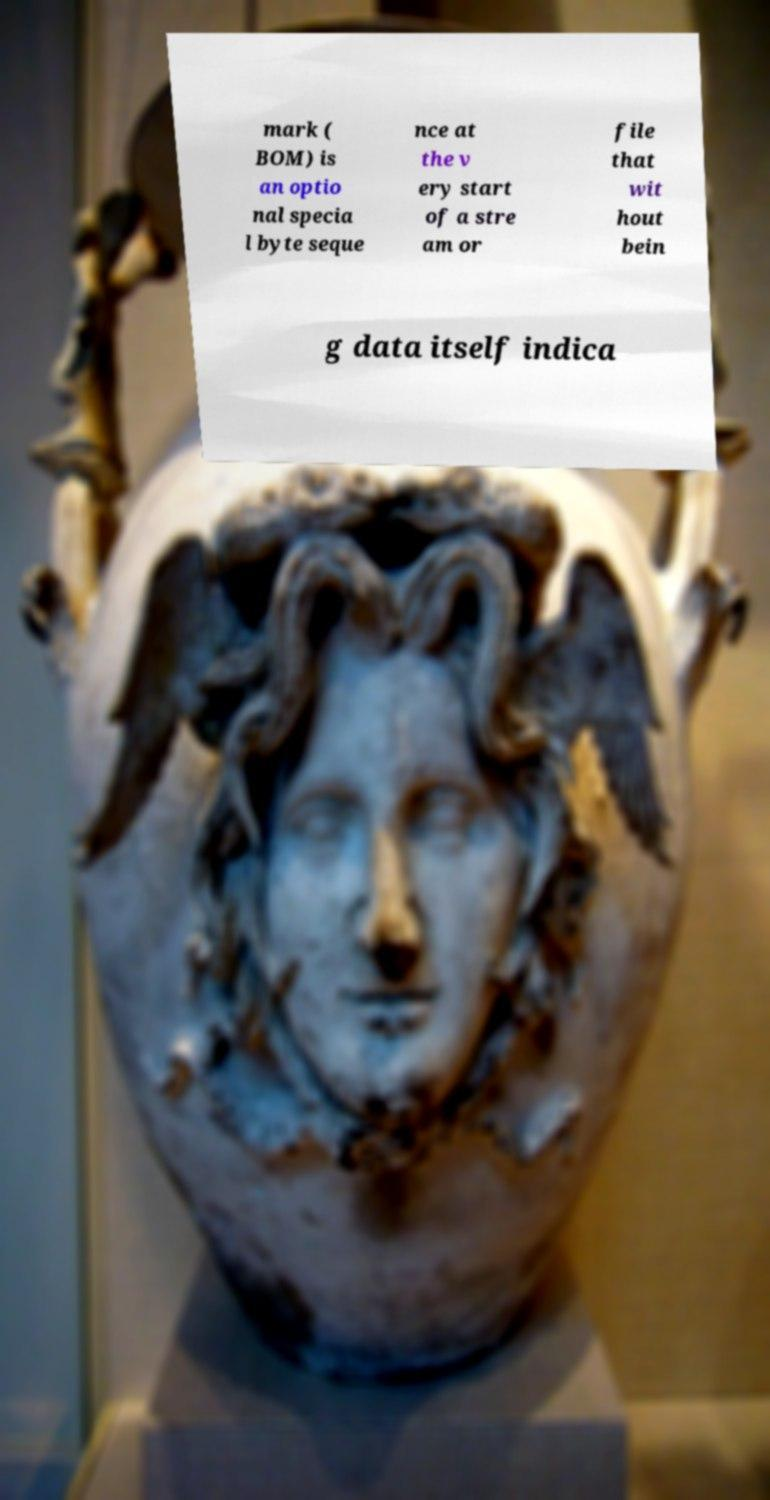What messages or text are displayed in this image? I need them in a readable, typed format. mark ( BOM) is an optio nal specia l byte seque nce at the v ery start of a stre am or file that wit hout bein g data itself indica 